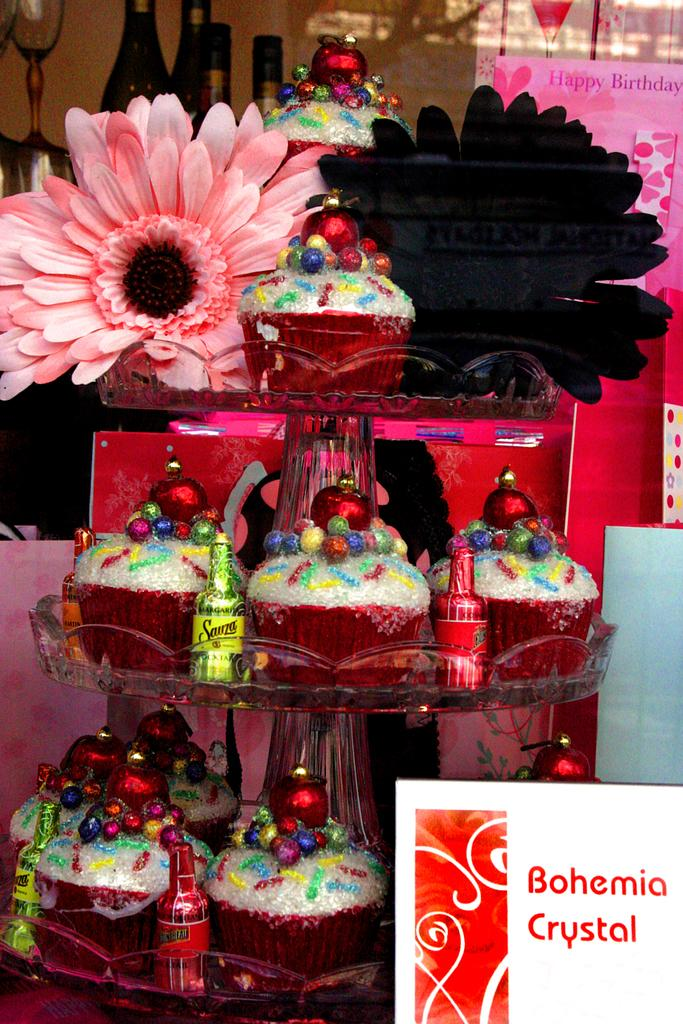What types of containers are visible in the image? There are bottles and glasses in the image. What other items can be seen in the image? There are flowers, cupcakes, decorative items, and cards in the image. Can you describe the decorative items in the image? Unfortunately, the provided facts do not give specific details about the decorative items. Are there any other objects in the image besides the ones mentioned? Yes, there are other objects in the image, but their descriptions are not provided in the facts. What is the income of the actor in the image? There is no actor present in the image, so it is not possible to determine their income. What is the actor doing with their pocket in the image? There is no actor present in the image, so it is not possible to determine any actions related to a pocket. 